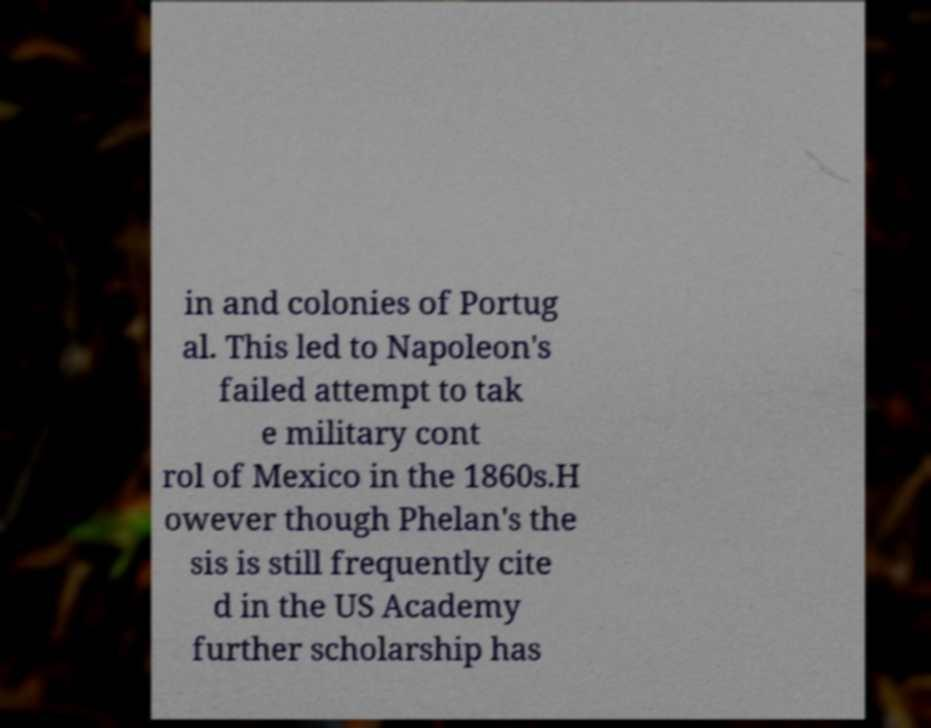Can you read and provide the text displayed in the image?This photo seems to have some interesting text. Can you extract and type it out for me? in and colonies of Portug al. This led to Napoleon's failed attempt to tak e military cont rol of Mexico in the 1860s.H owever though Phelan's the sis is still frequently cite d in the US Academy further scholarship has 